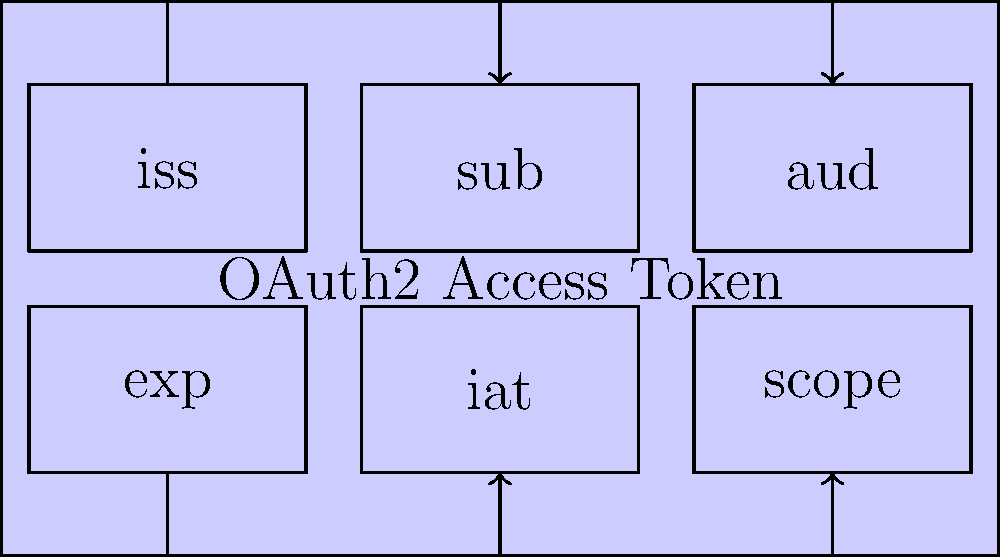Which of the following claims in an OAuth2 access token typically represents the expiration time of the token? To understand the structure of an OAuth2 access token, let's break down the common claims:

1. iss (Issuer): Identifies the principal that issued the token.
2. sub (Subject): The subject of the token, usually a unique identifier for the user.
3. aud (Audience): The intended recipient of the token.
4. exp (Expiration Time): The time at which the token becomes invalid.
5. iat (Issued At): The time at which the token was issued.
6. scope: The permissions associated with the token.

The expiration time of the token is crucial for security reasons, as it limits the window of opportunity for potential misuse if the token is compromised. This information is represented by the "exp" claim in the OAuth2 access token structure.

The "exp" claim contains a Unix timestamp (number of seconds since January 1, 1970, 00:00:00 UTC) that indicates when the token will expire. After this time, the token should no longer be considered valid by the resource server.

For a mobile app developer integrating OAuth2 authentication, it's important to handle token expiration properly. The app should check the "exp" claim and request a new token before the current one expires to ensure uninterrupted access to protected resources.
Answer: exp 